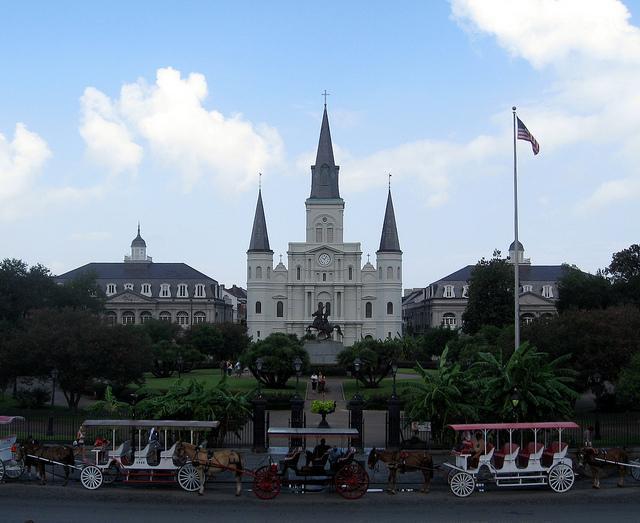What period of the day is it in the photo?
From the following four choices, select the correct answer to address the question.
Options: Late morning, night, evening, afternoon. Late morning. 